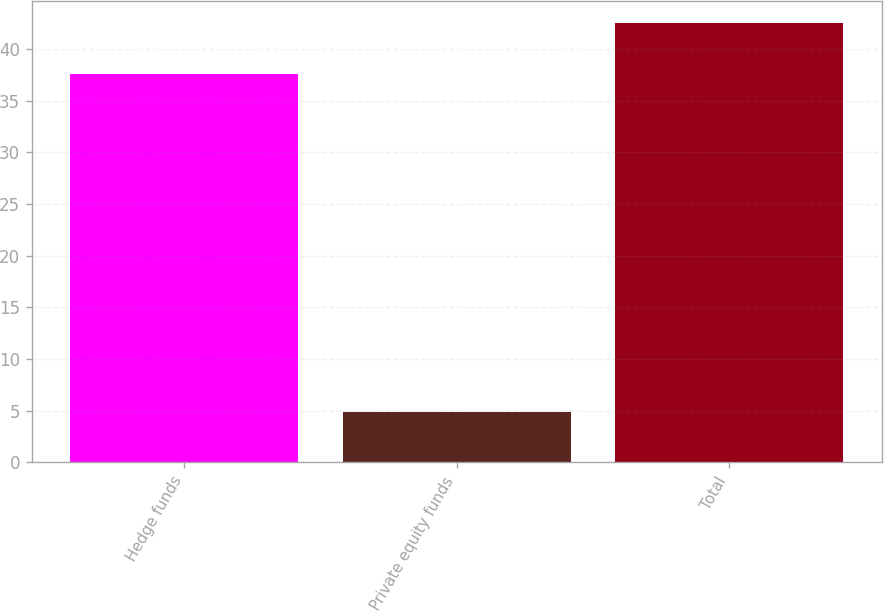Convert chart to OTSL. <chart><loc_0><loc_0><loc_500><loc_500><bar_chart><fcel>Hedge funds<fcel>Private equity funds<fcel>Total<nl><fcel>37.6<fcel>4.9<fcel>42.5<nl></chart> 